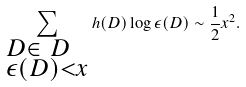<formula> <loc_0><loc_0><loc_500><loc_500>\sum _ { \begin{subarray} { c } D \in \ D \\ \epsilon ( D ) < x \end{subarray} } h ( D ) \log { \epsilon ( D ) } \sim \frac { 1 } { 2 } x ^ { 2 } .</formula> 